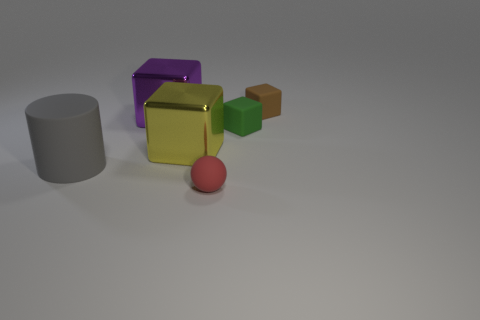Add 3 tiny rubber spheres. How many objects exist? 9 Subtract all cubes. How many objects are left? 2 Subtract all large metallic things. Subtract all small cubes. How many objects are left? 2 Add 1 gray cylinders. How many gray cylinders are left? 2 Add 2 tiny purple cylinders. How many tiny purple cylinders exist? 2 Subtract 0 green cylinders. How many objects are left? 6 